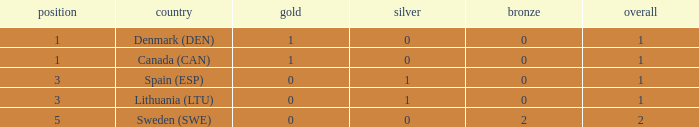What is the rank when there was less than 1 gold, 0 bronze, and more than 1 total? None. 